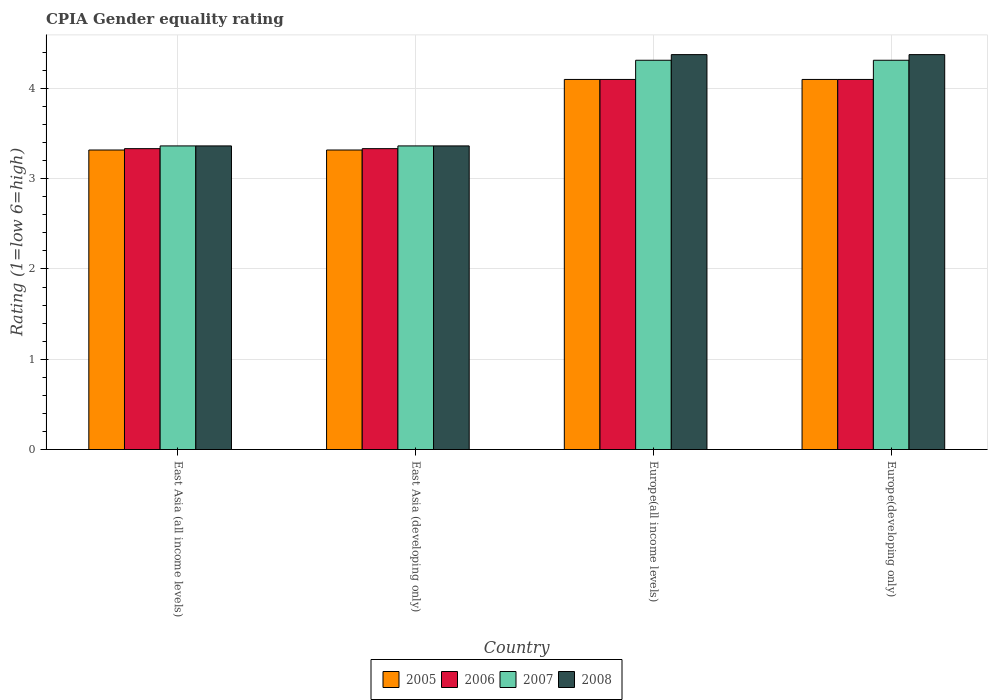How many groups of bars are there?
Keep it short and to the point. 4. Are the number of bars on each tick of the X-axis equal?
Offer a very short reply. Yes. How many bars are there on the 4th tick from the left?
Give a very brief answer. 4. How many bars are there on the 2nd tick from the right?
Provide a short and direct response. 4. What is the label of the 2nd group of bars from the left?
Keep it short and to the point. East Asia (developing only). In how many cases, is the number of bars for a given country not equal to the number of legend labels?
Give a very brief answer. 0. Across all countries, what is the maximum CPIA rating in 2008?
Keep it short and to the point. 4.38. Across all countries, what is the minimum CPIA rating in 2008?
Make the answer very short. 3.36. In which country was the CPIA rating in 2008 maximum?
Ensure brevity in your answer.  Europe(all income levels). In which country was the CPIA rating in 2006 minimum?
Keep it short and to the point. East Asia (all income levels). What is the total CPIA rating in 2007 in the graph?
Provide a short and direct response. 15.35. What is the difference between the CPIA rating in 2005 in East Asia (all income levels) and that in East Asia (developing only)?
Your answer should be compact. 0. What is the difference between the CPIA rating in 2007 in East Asia (all income levels) and the CPIA rating in 2006 in Europe(all income levels)?
Offer a terse response. -0.74. What is the average CPIA rating in 2008 per country?
Your answer should be very brief. 3.87. What is the difference between the CPIA rating of/in 2007 and CPIA rating of/in 2005 in East Asia (developing only)?
Your answer should be very brief. 0.05. In how many countries, is the CPIA rating in 2007 greater than 3?
Offer a very short reply. 4. What is the ratio of the CPIA rating in 2005 in Europe(all income levels) to that in Europe(developing only)?
Ensure brevity in your answer.  1. What is the difference between the highest and the second highest CPIA rating in 2005?
Your answer should be compact. -0.78. What is the difference between the highest and the lowest CPIA rating in 2007?
Give a very brief answer. 0.95. What does the 1st bar from the right in Europe(developing only) represents?
Your answer should be very brief. 2008. How many bars are there?
Your answer should be very brief. 16. Are all the bars in the graph horizontal?
Your response must be concise. No. How many countries are there in the graph?
Keep it short and to the point. 4. What is the difference between two consecutive major ticks on the Y-axis?
Your answer should be compact. 1. Are the values on the major ticks of Y-axis written in scientific E-notation?
Give a very brief answer. No. Does the graph contain any zero values?
Make the answer very short. No. Does the graph contain grids?
Your answer should be compact. Yes. How are the legend labels stacked?
Ensure brevity in your answer.  Horizontal. What is the title of the graph?
Provide a succinct answer. CPIA Gender equality rating. What is the label or title of the X-axis?
Provide a succinct answer. Country. What is the label or title of the Y-axis?
Your answer should be compact. Rating (1=low 6=high). What is the Rating (1=low 6=high) in 2005 in East Asia (all income levels)?
Provide a succinct answer. 3.32. What is the Rating (1=low 6=high) in 2006 in East Asia (all income levels)?
Your response must be concise. 3.33. What is the Rating (1=low 6=high) of 2007 in East Asia (all income levels)?
Keep it short and to the point. 3.36. What is the Rating (1=low 6=high) in 2008 in East Asia (all income levels)?
Keep it short and to the point. 3.36. What is the Rating (1=low 6=high) of 2005 in East Asia (developing only)?
Keep it short and to the point. 3.32. What is the Rating (1=low 6=high) in 2006 in East Asia (developing only)?
Keep it short and to the point. 3.33. What is the Rating (1=low 6=high) of 2007 in East Asia (developing only)?
Your answer should be compact. 3.36. What is the Rating (1=low 6=high) of 2008 in East Asia (developing only)?
Offer a terse response. 3.36. What is the Rating (1=low 6=high) in 2005 in Europe(all income levels)?
Offer a terse response. 4.1. What is the Rating (1=low 6=high) in 2006 in Europe(all income levels)?
Ensure brevity in your answer.  4.1. What is the Rating (1=low 6=high) of 2007 in Europe(all income levels)?
Keep it short and to the point. 4.31. What is the Rating (1=low 6=high) of 2008 in Europe(all income levels)?
Offer a very short reply. 4.38. What is the Rating (1=low 6=high) of 2007 in Europe(developing only)?
Your answer should be very brief. 4.31. What is the Rating (1=low 6=high) in 2008 in Europe(developing only)?
Your answer should be compact. 4.38. Across all countries, what is the maximum Rating (1=low 6=high) of 2005?
Provide a short and direct response. 4.1. Across all countries, what is the maximum Rating (1=low 6=high) in 2006?
Your response must be concise. 4.1. Across all countries, what is the maximum Rating (1=low 6=high) in 2007?
Ensure brevity in your answer.  4.31. Across all countries, what is the maximum Rating (1=low 6=high) of 2008?
Your response must be concise. 4.38. Across all countries, what is the minimum Rating (1=low 6=high) of 2005?
Offer a very short reply. 3.32. Across all countries, what is the minimum Rating (1=low 6=high) of 2006?
Provide a short and direct response. 3.33. Across all countries, what is the minimum Rating (1=low 6=high) in 2007?
Offer a terse response. 3.36. Across all countries, what is the minimum Rating (1=low 6=high) of 2008?
Provide a succinct answer. 3.36. What is the total Rating (1=low 6=high) in 2005 in the graph?
Provide a short and direct response. 14.84. What is the total Rating (1=low 6=high) in 2006 in the graph?
Make the answer very short. 14.87. What is the total Rating (1=low 6=high) in 2007 in the graph?
Provide a succinct answer. 15.35. What is the total Rating (1=low 6=high) in 2008 in the graph?
Your response must be concise. 15.48. What is the difference between the Rating (1=low 6=high) in 2005 in East Asia (all income levels) and that in East Asia (developing only)?
Provide a short and direct response. 0. What is the difference between the Rating (1=low 6=high) of 2006 in East Asia (all income levels) and that in East Asia (developing only)?
Ensure brevity in your answer.  0. What is the difference between the Rating (1=low 6=high) of 2008 in East Asia (all income levels) and that in East Asia (developing only)?
Offer a very short reply. 0. What is the difference between the Rating (1=low 6=high) of 2005 in East Asia (all income levels) and that in Europe(all income levels)?
Give a very brief answer. -0.78. What is the difference between the Rating (1=low 6=high) of 2006 in East Asia (all income levels) and that in Europe(all income levels)?
Keep it short and to the point. -0.77. What is the difference between the Rating (1=low 6=high) in 2007 in East Asia (all income levels) and that in Europe(all income levels)?
Your answer should be compact. -0.95. What is the difference between the Rating (1=low 6=high) in 2008 in East Asia (all income levels) and that in Europe(all income levels)?
Keep it short and to the point. -1.01. What is the difference between the Rating (1=low 6=high) in 2005 in East Asia (all income levels) and that in Europe(developing only)?
Offer a very short reply. -0.78. What is the difference between the Rating (1=low 6=high) in 2006 in East Asia (all income levels) and that in Europe(developing only)?
Keep it short and to the point. -0.77. What is the difference between the Rating (1=low 6=high) in 2007 in East Asia (all income levels) and that in Europe(developing only)?
Your answer should be compact. -0.95. What is the difference between the Rating (1=low 6=high) of 2008 in East Asia (all income levels) and that in Europe(developing only)?
Provide a short and direct response. -1.01. What is the difference between the Rating (1=low 6=high) of 2005 in East Asia (developing only) and that in Europe(all income levels)?
Make the answer very short. -0.78. What is the difference between the Rating (1=low 6=high) of 2006 in East Asia (developing only) and that in Europe(all income levels)?
Provide a short and direct response. -0.77. What is the difference between the Rating (1=low 6=high) in 2007 in East Asia (developing only) and that in Europe(all income levels)?
Your response must be concise. -0.95. What is the difference between the Rating (1=low 6=high) in 2008 in East Asia (developing only) and that in Europe(all income levels)?
Give a very brief answer. -1.01. What is the difference between the Rating (1=low 6=high) of 2005 in East Asia (developing only) and that in Europe(developing only)?
Make the answer very short. -0.78. What is the difference between the Rating (1=low 6=high) in 2006 in East Asia (developing only) and that in Europe(developing only)?
Your response must be concise. -0.77. What is the difference between the Rating (1=low 6=high) of 2007 in East Asia (developing only) and that in Europe(developing only)?
Keep it short and to the point. -0.95. What is the difference between the Rating (1=low 6=high) of 2008 in East Asia (developing only) and that in Europe(developing only)?
Your answer should be very brief. -1.01. What is the difference between the Rating (1=low 6=high) in 2005 in Europe(all income levels) and that in Europe(developing only)?
Your response must be concise. 0. What is the difference between the Rating (1=low 6=high) of 2006 in Europe(all income levels) and that in Europe(developing only)?
Offer a very short reply. 0. What is the difference between the Rating (1=low 6=high) of 2008 in Europe(all income levels) and that in Europe(developing only)?
Ensure brevity in your answer.  0. What is the difference between the Rating (1=low 6=high) in 2005 in East Asia (all income levels) and the Rating (1=low 6=high) in 2006 in East Asia (developing only)?
Your response must be concise. -0.02. What is the difference between the Rating (1=low 6=high) of 2005 in East Asia (all income levels) and the Rating (1=low 6=high) of 2007 in East Asia (developing only)?
Offer a terse response. -0.05. What is the difference between the Rating (1=low 6=high) in 2005 in East Asia (all income levels) and the Rating (1=low 6=high) in 2008 in East Asia (developing only)?
Offer a terse response. -0.05. What is the difference between the Rating (1=low 6=high) in 2006 in East Asia (all income levels) and the Rating (1=low 6=high) in 2007 in East Asia (developing only)?
Offer a very short reply. -0.03. What is the difference between the Rating (1=low 6=high) of 2006 in East Asia (all income levels) and the Rating (1=low 6=high) of 2008 in East Asia (developing only)?
Your answer should be very brief. -0.03. What is the difference between the Rating (1=low 6=high) in 2007 in East Asia (all income levels) and the Rating (1=low 6=high) in 2008 in East Asia (developing only)?
Your answer should be very brief. 0. What is the difference between the Rating (1=low 6=high) of 2005 in East Asia (all income levels) and the Rating (1=low 6=high) of 2006 in Europe(all income levels)?
Provide a succinct answer. -0.78. What is the difference between the Rating (1=low 6=high) of 2005 in East Asia (all income levels) and the Rating (1=low 6=high) of 2007 in Europe(all income levels)?
Make the answer very short. -0.99. What is the difference between the Rating (1=low 6=high) in 2005 in East Asia (all income levels) and the Rating (1=low 6=high) in 2008 in Europe(all income levels)?
Provide a short and direct response. -1.06. What is the difference between the Rating (1=low 6=high) of 2006 in East Asia (all income levels) and the Rating (1=low 6=high) of 2007 in Europe(all income levels)?
Your answer should be compact. -0.98. What is the difference between the Rating (1=low 6=high) of 2006 in East Asia (all income levels) and the Rating (1=low 6=high) of 2008 in Europe(all income levels)?
Offer a terse response. -1.04. What is the difference between the Rating (1=low 6=high) in 2007 in East Asia (all income levels) and the Rating (1=low 6=high) in 2008 in Europe(all income levels)?
Keep it short and to the point. -1.01. What is the difference between the Rating (1=low 6=high) in 2005 in East Asia (all income levels) and the Rating (1=low 6=high) in 2006 in Europe(developing only)?
Ensure brevity in your answer.  -0.78. What is the difference between the Rating (1=low 6=high) in 2005 in East Asia (all income levels) and the Rating (1=low 6=high) in 2007 in Europe(developing only)?
Provide a short and direct response. -0.99. What is the difference between the Rating (1=low 6=high) in 2005 in East Asia (all income levels) and the Rating (1=low 6=high) in 2008 in Europe(developing only)?
Provide a short and direct response. -1.06. What is the difference between the Rating (1=low 6=high) in 2006 in East Asia (all income levels) and the Rating (1=low 6=high) in 2007 in Europe(developing only)?
Provide a succinct answer. -0.98. What is the difference between the Rating (1=low 6=high) of 2006 in East Asia (all income levels) and the Rating (1=low 6=high) of 2008 in Europe(developing only)?
Give a very brief answer. -1.04. What is the difference between the Rating (1=low 6=high) in 2007 in East Asia (all income levels) and the Rating (1=low 6=high) in 2008 in Europe(developing only)?
Your response must be concise. -1.01. What is the difference between the Rating (1=low 6=high) of 2005 in East Asia (developing only) and the Rating (1=low 6=high) of 2006 in Europe(all income levels)?
Provide a succinct answer. -0.78. What is the difference between the Rating (1=low 6=high) in 2005 in East Asia (developing only) and the Rating (1=low 6=high) in 2007 in Europe(all income levels)?
Give a very brief answer. -0.99. What is the difference between the Rating (1=low 6=high) of 2005 in East Asia (developing only) and the Rating (1=low 6=high) of 2008 in Europe(all income levels)?
Your response must be concise. -1.06. What is the difference between the Rating (1=low 6=high) in 2006 in East Asia (developing only) and the Rating (1=low 6=high) in 2007 in Europe(all income levels)?
Ensure brevity in your answer.  -0.98. What is the difference between the Rating (1=low 6=high) in 2006 in East Asia (developing only) and the Rating (1=low 6=high) in 2008 in Europe(all income levels)?
Your answer should be compact. -1.04. What is the difference between the Rating (1=low 6=high) of 2007 in East Asia (developing only) and the Rating (1=low 6=high) of 2008 in Europe(all income levels)?
Keep it short and to the point. -1.01. What is the difference between the Rating (1=low 6=high) in 2005 in East Asia (developing only) and the Rating (1=low 6=high) in 2006 in Europe(developing only)?
Provide a succinct answer. -0.78. What is the difference between the Rating (1=low 6=high) in 2005 in East Asia (developing only) and the Rating (1=low 6=high) in 2007 in Europe(developing only)?
Provide a short and direct response. -0.99. What is the difference between the Rating (1=low 6=high) in 2005 in East Asia (developing only) and the Rating (1=low 6=high) in 2008 in Europe(developing only)?
Offer a very short reply. -1.06. What is the difference between the Rating (1=low 6=high) of 2006 in East Asia (developing only) and the Rating (1=low 6=high) of 2007 in Europe(developing only)?
Make the answer very short. -0.98. What is the difference between the Rating (1=low 6=high) in 2006 in East Asia (developing only) and the Rating (1=low 6=high) in 2008 in Europe(developing only)?
Keep it short and to the point. -1.04. What is the difference between the Rating (1=low 6=high) of 2007 in East Asia (developing only) and the Rating (1=low 6=high) of 2008 in Europe(developing only)?
Keep it short and to the point. -1.01. What is the difference between the Rating (1=low 6=high) of 2005 in Europe(all income levels) and the Rating (1=low 6=high) of 2006 in Europe(developing only)?
Offer a very short reply. 0. What is the difference between the Rating (1=low 6=high) in 2005 in Europe(all income levels) and the Rating (1=low 6=high) in 2007 in Europe(developing only)?
Offer a very short reply. -0.21. What is the difference between the Rating (1=low 6=high) of 2005 in Europe(all income levels) and the Rating (1=low 6=high) of 2008 in Europe(developing only)?
Provide a short and direct response. -0.28. What is the difference between the Rating (1=low 6=high) of 2006 in Europe(all income levels) and the Rating (1=low 6=high) of 2007 in Europe(developing only)?
Your response must be concise. -0.21. What is the difference between the Rating (1=low 6=high) of 2006 in Europe(all income levels) and the Rating (1=low 6=high) of 2008 in Europe(developing only)?
Your response must be concise. -0.28. What is the difference between the Rating (1=low 6=high) of 2007 in Europe(all income levels) and the Rating (1=low 6=high) of 2008 in Europe(developing only)?
Your answer should be very brief. -0.06. What is the average Rating (1=low 6=high) in 2005 per country?
Give a very brief answer. 3.71. What is the average Rating (1=low 6=high) of 2006 per country?
Keep it short and to the point. 3.72. What is the average Rating (1=low 6=high) in 2007 per country?
Offer a terse response. 3.84. What is the average Rating (1=low 6=high) of 2008 per country?
Your answer should be compact. 3.87. What is the difference between the Rating (1=low 6=high) in 2005 and Rating (1=low 6=high) in 2006 in East Asia (all income levels)?
Make the answer very short. -0.02. What is the difference between the Rating (1=low 6=high) in 2005 and Rating (1=low 6=high) in 2007 in East Asia (all income levels)?
Ensure brevity in your answer.  -0.05. What is the difference between the Rating (1=low 6=high) of 2005 and Rating (1=low 6=high) of 2008 in East Asia (all income levels)?
Your answer should be compact. -0.05. What is the difference between the Rating (1=low 6=high) in 2006 and Rating (1=low 6=high) in 2007 in East Asia (all income levels)?
Make the answer very short. -0.03. What is the difference between the Rating (1=low 6=high) of 2006 and Rating (1=low 6=high) of 2008 in East Asia (all income levels)?
Your answer should be very brief. -0.03. What is the difference between the Rating (1=low 6=high) in 2005 and Rating (1=low 6=high) in 2006 in East Asia (developing only)?
Offer a terse response. -0.02. What is the difference between the Rating (1=low 6=high) in 2005 and Rating (1=low 6=high) in 2007 in East Asia (developing only)?
Your response must be concise. -0.05. What is the difference between the Rating (1=low 6=high) in 2005 and Rating (1=low 6=high) in 2008 in East Asia (developing only)?
Ensure brevity in your answer.  -0.05. What is the difference between the Rating (1=low 6=high) in 2006 and Rating (1=low 6=high) in 2007 in East Asia (developing only)?
Offer a very short reply. -0.03. What is the difference between the Rating (1=low 6=high) of 2006 and Rating (1=low 6=high) of 2008 in East Asia (developing only)?
Provide a short and direct response. -0.03. What is the difference between the Rating (1=low 6=high) of 2007 and Rating (1=low 6=high) of 2008 in East Asia (developing only)?
Provide a short and direct response. 0. What is the difference between the Rating (1=low 6=high) of 2005 and Rating (1=low 6=high) of 2007 in Europe(all income levels)?
Offer a terse response. -0.21. What is the difference between the Rating (1=low 6=high) in 2005 and Rating (1=low 6=high) in 2008 in Europe(all income levels)?
Your response must be concise. -0.28. What is the difference between the Rating (1=low 6=high) in 2006 and Rating (1=low 6=high) in 2007 in Europe(all income levels)?
Provide a short and direct response. -0.21. What is the difference between the Rating (1=low 6=high) in 2006 and Rating (1=low 6=high) in 2008 in Europe(all income levels)?
Keep it short and to the point. -0.28. What is the difference between the Rating (1=low 6=high) of 2007 and Rating (1=low 6=high) of 2008 in Europe(all income levels)?
Keep it short and to the point. -0.06. What is the difference between the Rating (1=low 6=high) in 2005 and Rating (1=low 6=high) in 2006 in Europe(developing only)?
Offer a terse response. 0. What is the difference between the Rating (1=low 6=high) of 2005 and Rating (1=low 6=high) of 2007 in Europe(developing only)?
Provide a short and direct response. -0.21. What is the difference between the Rating (1=low 6=high) in 2005 and Rating (1=low 6=high) in 2008 in Europe(developing only)?
Your answer should be compact. -0.28. What is the difference between the Rating (1=low 6=high) in 2006 and Rating (1=low 6=high) in 2007 in Europe(developing only)?
Offer a very short reply. -0.21. What is the difference between the Rating (1=low 6=high) in 2006 and Rating (1=low 6=high) in 2008 in Europe(developing only)?
Give a very brief answer. -0.28. What is the difference between the Rating (1=low 6=high) in 2007 and Rating (1=low 6=high) in 2008 in Europe(developing only)?
Ensure brevity in your answer.  -0.06. What is the ratio of the Rating (1=low 6=high) in 2005 in East Asia (all income levels) to that in East Asia (developing only)?
Make the answer very short. 1. What is the ratio of the Rating (1=low 6=high) of 2008 in East Asia (all income levels) to that in East Asia (developing only)?
Provide a succinct answer. 1. What is the ratio of the Rating (1=low 6=high) of 2005 in East Asia (all income levels) to that in Europe(all income levels)?
Your answer should be very brief. 0.81. What is the ratio of the Rating (1=low 6=high) in 2006 in East Asia (all income levels) to that in Europe(all income levels)?
Offer a very short reply. 0.81. What is the ratio of the Rating (1=low 6=high) of 2007 in East Asia (all income levels) to that in Europe(all income levels)?
Make the answer very short. 0.78. What is the ratio of the Rating (1=low 6=high) of 2008 in East Asia (all income levels) to that in Europe(all income levels)?
Keep it short and to the point. 0.77. What is the ratio of the Rating (1=low 6=high) in 2005 in East Asia (all income levels) to that in Europe(developing only)?
Your answer should be very brief. 0.81. What is the ratio of the Rating (1=low 6=high) of 2006 in East Asia (all income levels) to that in Europe(developing only)?
Ensure brevity in your answer.  0.81. What is the ratio of the Rating (1=low 6=high) of 2007 in East Asia (all income levels) to that in Europe(developing only)?
Your answer should be compact. 0.78. What is the ratio of the Rating (1=low 6=high) of 2008 in East Asia (all income levels) to that in Europe(developing only)?
Offer a terse response. 0.77. What is the ratio of the Rating (1=low 6=high) of 2005 in East Asia (developing only) to that in Europe(all income levels)?
Provide a succinct answer. 0.81. What is the ratio of the Rating (1=low 6=high) of 2006 in East Asia (developing only) to that in Europe(all income levels)?
Keep it short and to the point. 0.81. What is the ratio of the Rating (1=low 6=high) of 2007 in East Asia (developing only) to that in Europe(all income levels)?
Make the answer very short. 0.78. What is the ratio of the Rating (1=low 6=high) of 2008 in East Asia (developing only) to that in Europe(all income levels)?
Make the answer very short. 0.77. What is the ratio of the Rating (1=low 6=high) of 2005 in East Asia (developing only) to that in Europe(developing only)?
Offer a terse response. 0.81. What is the ratio of the Rating (1=low 6=high) of 2006 in East Asia (developing only) to that in Europe(developing only)?
Offer a very short reply. 0.81. What is the ratio of the Rating (1=low 6=high) of 2007 in East Asia (developing only) to that in Europe(developing only)?
Your response must be concise. 0.78. What is the ratio of the Rating (1=low 6=high) in 2008 in East Asia (developing only) to that in Europe(developing only)?
Your answer should be compact. 0.77. What is the ratio of the Rating (1=low 6=high) in 2005 in Europe(all income levels) to that in Europe(developing only)?
Give a very brief answer. 1. What is the ratio of the Rating (1=low 6=high) of 2008 in Europe(all income levels) to that in Europe(developing only)?
Your answer should be very brief. 1. What is the difference between the highest and the second highest Rating (1=low 6=high) of 2008?
Make the answer very short. 0. What is the difference between the highest and the lowest Rating (1=low 6=high) of 2005?
Make the answer very short. 0.78. What is the difference between the highest and the lowest Rating (1=low 6=high) of 2006?
Ensure brevity in your answer.  0.77. What is the difference between the highest and the lowest Rating (1=low 6=high) in 2007?
Make the answer very short. 0.95. What is the difference between the highest and the lowest Rating (1=low 6=high) of 2008?
Provide a succinct answer. 1.01. 